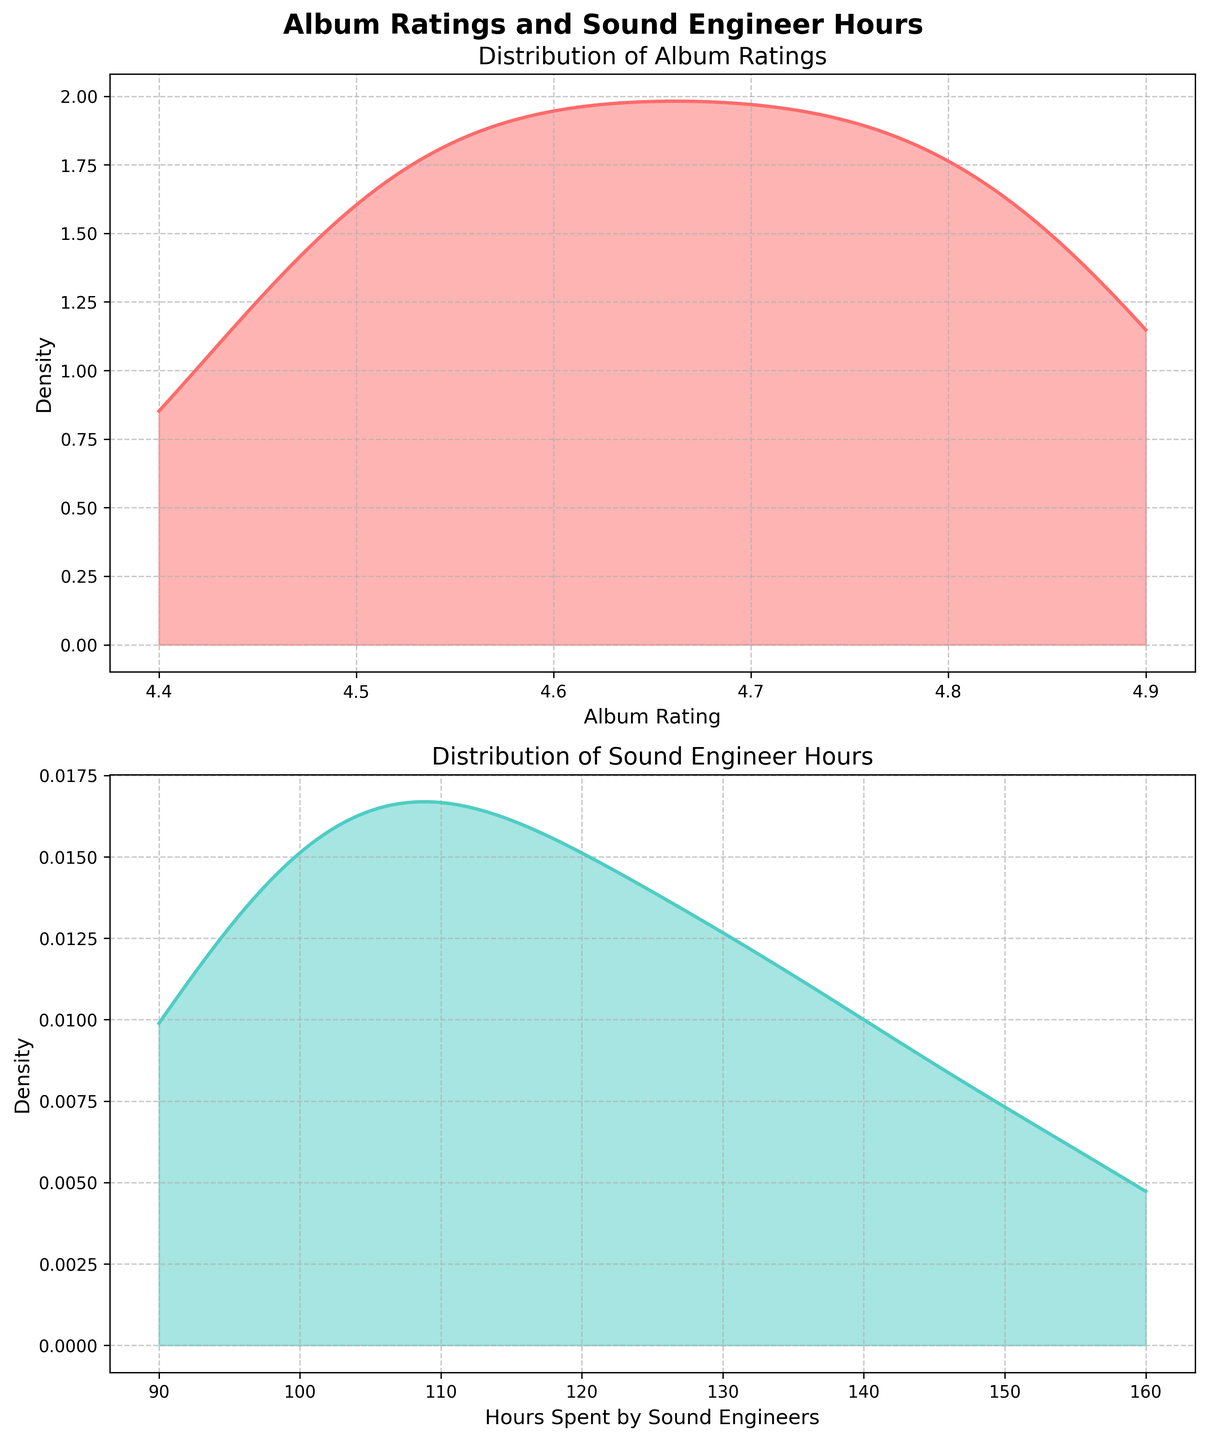What is the title of the plot? The title is typically found at the top of the figure and is meant to provide an overview of the plot's content.
Answer: Album Ratings and Sound Engineer Hours What is the range of album ratings displayed in the plot? Look at the x-axis of the first subplot to identify the minimum and maximum values.
Answer: 4.4 to 4.9 Which color represents the density plot for 'Hours Spent by Sound Engineers'? The second subplot has a specific color for the density plot.
Answer: Teal (or light green) Between album ratings and hours spent, which one seems to have a more spread-out distribution? Compare the width of the density plots in both subplots; a wider distribution means more spread-out data.
Answer: Hours Spent For the density plot of Hours Spent, identify the range within which most of the data falls (the highest density region). Look for the peak and determine between which x-values the peak extends.
Answer: 100 to 160 hours How do the peaks of the density plots for album ratings and hours spent compare? Compare the peak heights in both subplots to see which one has a higher maximum density.
Answer: The peaks are similar in height Does the density plot for album ratings show a skewness? If yes, which direction? Observe the shape of the density plot; if it's not symmetrical, note the direction it stretches out more.
Answer: Slightly left-skewed What is the most frequent album rating based on the density plot? The most frequent value corresponds to the peak of the density plot in the first subplot.
Answer: 4.8 By looking at the density plot for 'Hours Spent by Sound Engineers,' can we determine if there are any outliers? Outliers are typically indicated by isolated peaks or values far from the main bulk of the distribution.
Answer: No clear outliers Is there a visible correlation between higher album ratings and increased hours spent in post-production? Since the subplots are not overlaid, we need to infer this by observing the spread and relationship of both density plots.
Answer: Yes, more hours generally correlate with higher ratings 